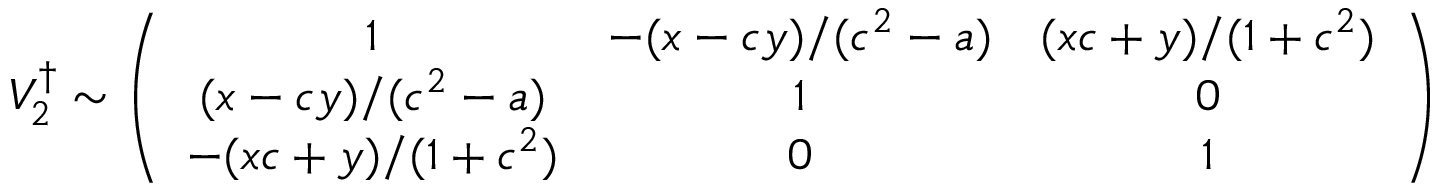Convert formula to latex. <formula><loc_0><loc_0><loc_500><loc_500>V _ { 2 } ^ { \dag } \sim \left ( \begin{array} { c c c } { 1 } & { { - ( x - c y ) / ( c ^ { 2 } - a ) } } & { { ( x c + y ) / ( 1 + c ^ { 2 } ) } } \\ { { ( x - c y ) / ( c ^ { 2 } - a ) } } & { 1 } & { 0 } \\ { { - ( x c + y ) / ( 1 + c ^ { 2 } ) } } & { 0 } & { 1 } \end{array} \right )</formula> 